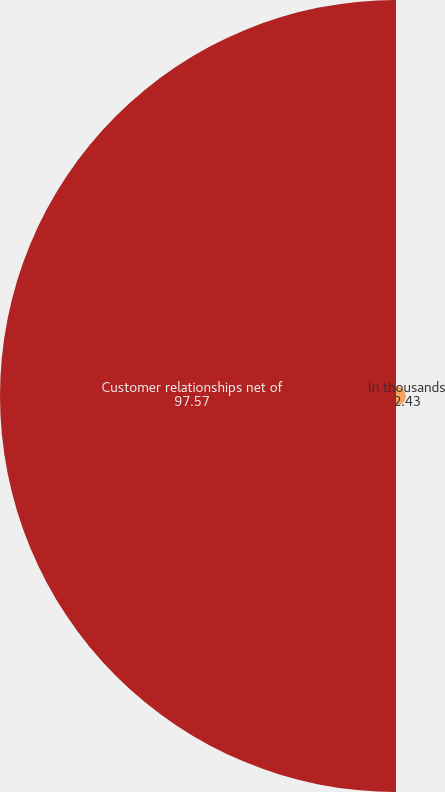<chart> <loc_0><loc_0><loc_500><loc_500><pie_chart><fcel>In thousands<fcel>Customer relationships net of<nl><fcel>2.43%<fcel>97.57%<nl></chart> 